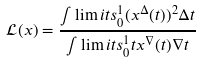Convert formula to latex. <formula><loc_0><loc_0><loc_500><loc_500>\mathcal { L } ( x ) = \frac { \int \lim i t s _ { 0 } ^ { 1 } ( x ^ { \Delta } ( t ) ) ^ { 2 } \Delta t } { \int \lim i t s _ { 0 } ^ { 1 } t x ^ { \nabla } ( t ) \nabla t }</formula> 